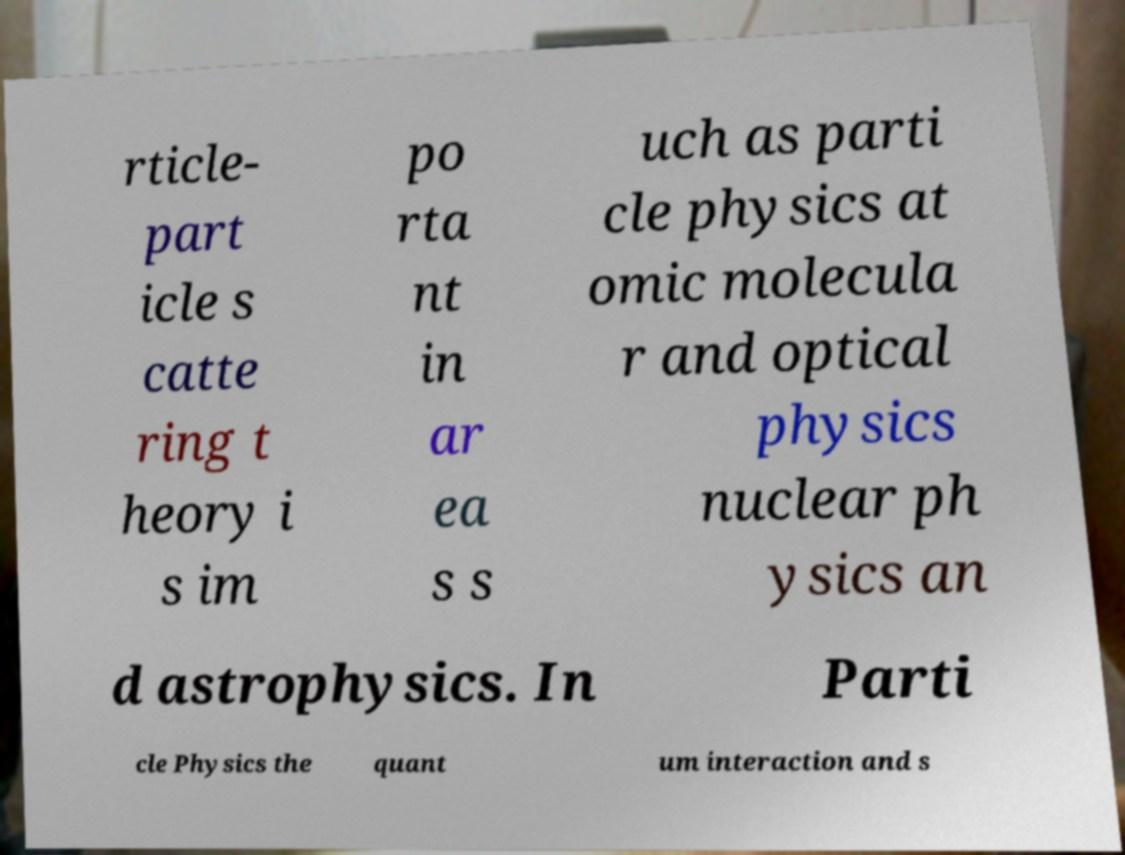I need the written content from this picture converted into text. Can you do that? rticle- part icle s catte ring t heory i s im po rta nt in ar ea s s uch as parti cle physics at omic molecula r and optical physics nuclear ph ysics an d astrophysics. In Parti cle Physics the quant um interaction and s 